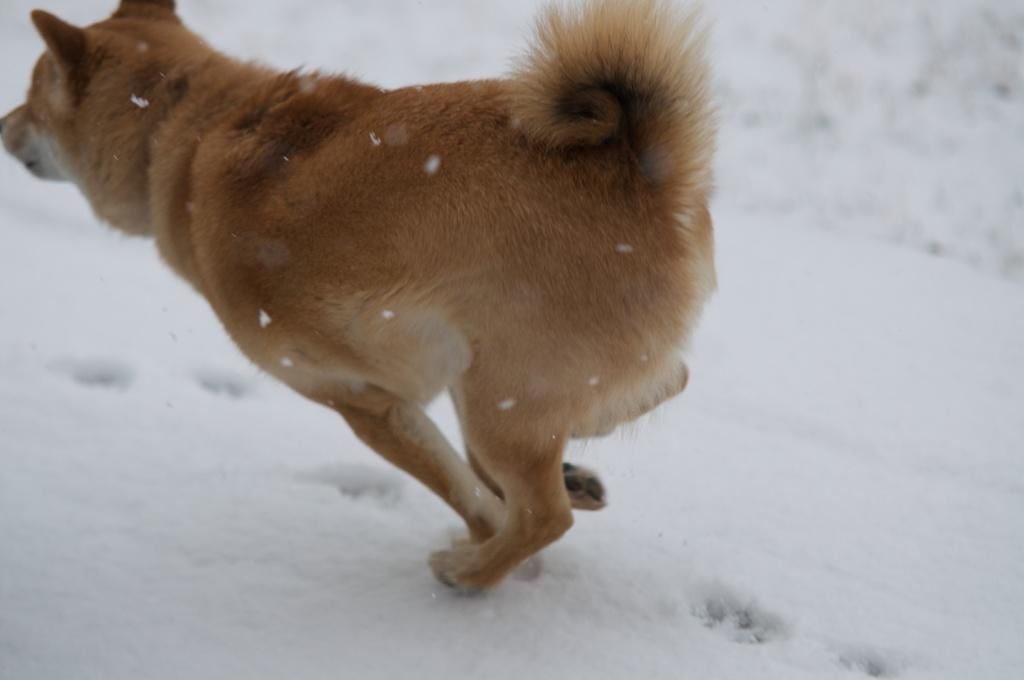What animal is present in the image? There is a dog in the image. What is the dog doing in the image? The dog is running in the image. What type of terrain is the dog running on? The dog is running on snow in the image. What type of popcorn is the dog holding in its mouth while running on the snow? There is no popcorn present in the image; the dog is not holding anything in its mouth. 